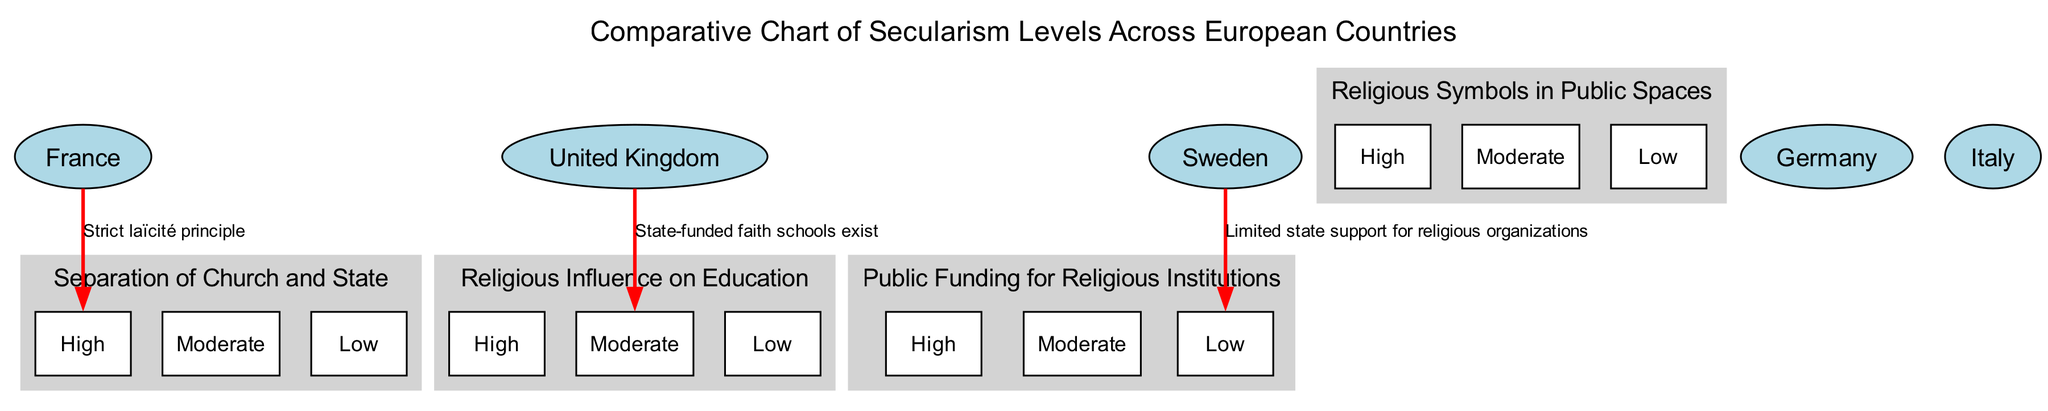What country has a high level of secularism for the separation of church and state? The diagram indicates that France has a high level of secularism regarding the separation of church and state, as noted in the key examples section.
Answer: France Which country has a moderate level of religious influence on education? By looking at the key examples, we see that the United Kingdom is identified with a moderate level concerning religious influence on education.
Answer: United Kingdom How many secularism factors are listed in the diagram? The diagram includes four secularism factors, which can be counted directly from the relevant section.
Answer: 4 What is the secularism level for Sweden regarding public funding for religious institutions? The diagram specifies that Sweden has a low level concerning public funding for religious institutions based on the key example provided.
Answer: Low Which country is associated with the note "State-funded faith schools exist"? From the key examples, we find that this note relates to the United Kingdom.
Answer: United Kingdom What relationship is shown between France and the separation of church and state? The diagram illustrates a direct edge from France to the node representing high secularism for the separation of church and state, indicating a strong relationship.
Answer: High Which secularism level is shown for Italy across all factors? The diagram does not provide any specific examples or connections for Italy, indicating it's either not assessed or not applicable in this chart.
Answer: Not applicable How does Sweden's level of public funding for religious institutions compare to other countries? The diagram depicts Sweden with a low level for this factor, which is contrasted with other countries like France (high) and the United Kingdom (moderate), indicating Sweden has the least support.
Answer: Low 